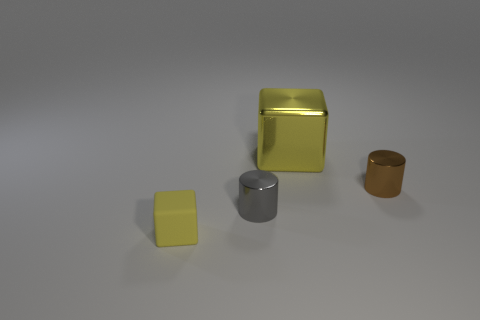Add 1 gray cylinders. How many objects exist? 5 Add 1 brown cylinders. How many brown cylinders exist? 2 Subtract 0 blue balls. How many objects are left? 4 Subtract all brown cylinders. Subtract all yellow rubber things. How many objects are left? 2 Add 2 tiny brown shiny things. How many tiny brown shiny things are left? 3 